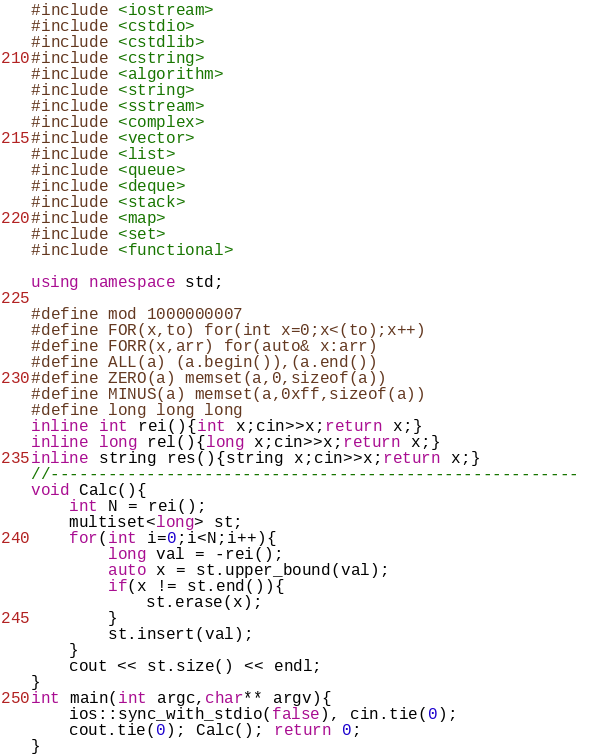Convert code to text. <code><loc_0><loc_0><loc_500><loc_500><_C++_>#include <iostream>
#include <cstdio>
#include <cstdlib>
#include <cstring>
#include <algorithm>
#include <string>
#include <sstream>
#include <complex>
#include <vector>
#include <list>
#include <queue>
#include <deque>
#include <stack>
#include <map>
#include <set>
#include <functional>

using namespace std;
 
#define mod 1000000007
#define FOR(x,to) for(int x=0;x<(to);x++)
#define FORR(x,arr) for(auto& x:arr)
#define ALL(a) (a.begin()),(a.end())
#define ZERO(a) memset(a,0,sizeof(a))
#define MINUS(a) memset(a,0xff,sizeof(a))
#define long long long
inline int rei(){int x;cin>>x;return x;}
inline long rel(){long x;cin>>x;return x;}
inline string res(){string x;cin>>x;return x;}
//------------------------------------------------------- 
void Calc(){
	int N = rei();
	multiset<long> st;
	for(int i=0;i<N;i++){
		long val = -rei();
		auto x = st.upper_bound(val);
		if(x != st.end()){
			st.erase(x);
		}
		st.insert(val);
	}
	cout << st.size() << endl;
}
int main(int argc,char** argv){
	ios::sync_with_stdio(false), cin.tie(0);
	cout.tie(0); Calc(); return 0;
}</code> 